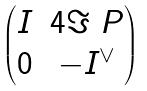Convert formula to latex. <formula><loc_0><loc_0><loc_500><loc_500>\begin{pmatrix} I & 4 \Im \ P \\ 0 & - I ^ { \vee } \end{pmatrix}</formula> 